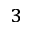Convert formula to latex. <formula><loc_0><loc_0><loc_500><loc_500>^ { 3 }</formula> 